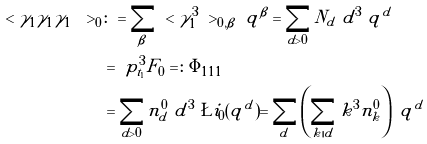<formula> <loc_0><loc_0><loc_500><loc_500>\ < \gamma _ { 1 } \gamma _ { 1 } \gamma _ { 1 } \ > _ { 0 } & \colon = \sum _ { \beta } \ < \gamma _ { 1 } ^ { 3 } \ > _ { 0 , \beta } \ q ^ { \beta } = \sum _ { d > 0 } N _ { d } \ d ^ { 3 } \ q ^ { d } \\ & = \ p _ { t _ { 1 } } ^ { 3 } \tilde { F _ { 0 } } = \colon \Phi _ { 1 1 1 } \\ & = \sum _ { d > 0 } \tilde { n } ^ { 0 } _ { d } \ d ^ { 3 } \ \L i _ { 0 } ( q ^ { d } ) = \sum _ { d } \left ( \sum _ { k | d } k ^ { 3 } \tilde { n } ^ { 0 } _ { k } \right ) \ q ^ { d }</formula> 